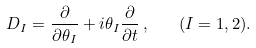<formula> <loc_0><loc_0><loc_500><loc_500>D _ { I } = \frac { \partial } { \partial \theta _ { I } } + i \theta _ { I } \frac { \partial } { \partial t } \, , \quad ( I = 1 , 2 ) .</formula> 